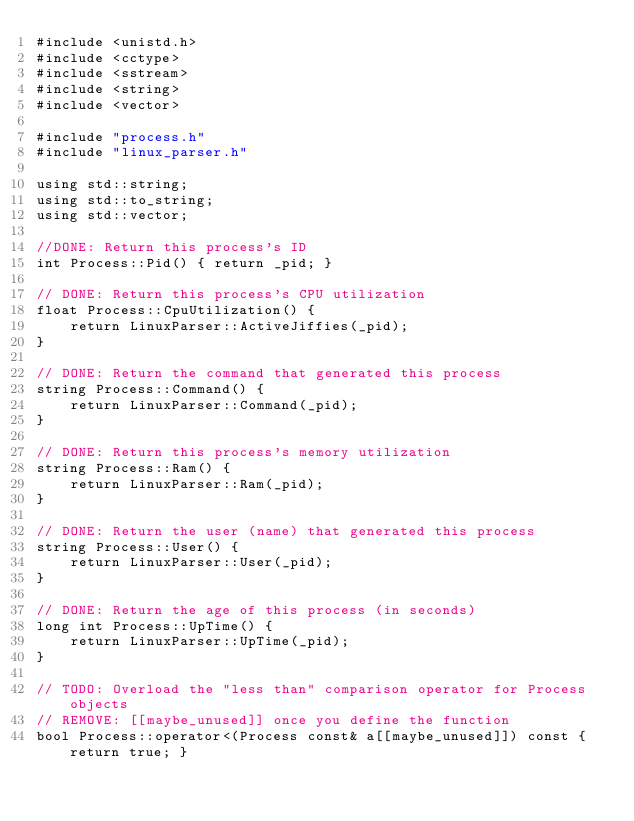<code> <loc_0><loc_0><loc_500><loc_500><_C++_>#include <unistd.h>
#include <cctype>
#include <sstream>
#include <string>
#include <vector>

#include "process.h"
#include "linux_parser.h"

using std::string;
using std::to_string;
using std::vector;

//DONE: Return this process's ID
int Process::Pid() { return _pid; }

// DONE: Return this process's CPU utilization
float Process::CpuUtilization() { 
    return LinuxParser::ActiveJiffies(_pid); 
}

// DONE: Return the command that generated this process
string Process::Command() { 
    return LinuxParser::Command(_pid); 
}

// DONE: Return this process's memory utilization
string Process::Ram() { 
    return LinuxParser::Ram(_pid); 
}

// DONE: Return the user (name) that generated this process
string Process::User() { 
    return LinuxParser::User(_pid); 
}

// DONE: Return the age of this process (in seconds)
long int Process::UpTime() { 
    return LinuxParser::UpTime(_pid); 
}

// TODO: Overload the "less than" comparison operator for Process objects
// REMOVE: [[maybe_unused]] once you define the function
bool Process::operator<(Process const& a[[maybe_unused]]) const { return true; }</code> 